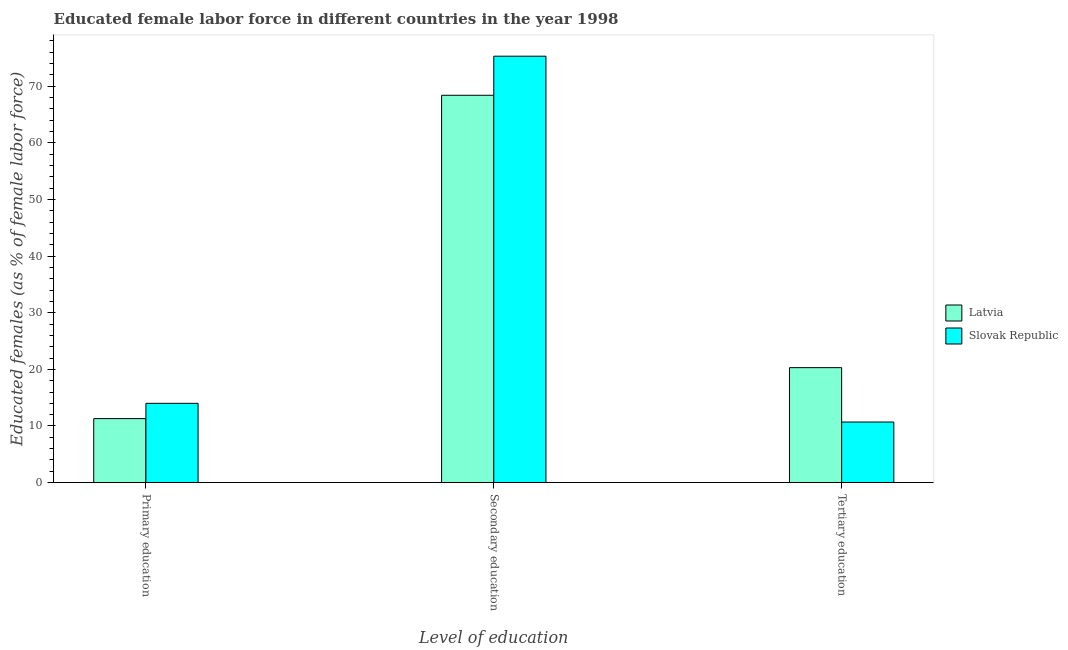How many groups of bars are there?
Provide a short and direct response. 3. Are the number of bars per tick equal to the number of legend labels?
Your response must be concise. Yes. How many bars are there on the 1st tick from the left?
Ensure brevity in your answer.  2. How many bars are there on the 3rd tick from the right?
Give a very brief answer. 2. What is the label of the 3rd group of bars from the left?
Ensure brevity in your answer.  Tertiary education. What is the percentage of female labor force who received secondary education in Latvia?
Your answer should be compact. 68.4. Across all countries, what is the maximum percentage of female labor force who received primary education?
Provide a short and direct response. 14. Across all countries, what is the minimum percentage of female labor force who received tertiary education?
Make the answer very short. 10.7. In which country was the percentage of female labor force who received tertiary education maximum?
Make the answer very short. Latvia. In which country was the percentage of female labor force who received secondary education minimum?
Ensure brevity in your answer.  Latvia. What is the total percentage of female labor force who received primary education in the graph?
Give a very brief answer. 25.3. What is the difference between the percentage of female labor force who received secondary education in Latvia and that in Slovak Republic?
Make the answer very short. -6.9. What is the difference between the percentage of female labor force who received primary education in Slovak Republic and the percentage of female labor force who received secondary education in Latvia?
Make the answer very short. -54.4. What is the average percentage of female labor force who received tertiary education per country?
Offer a terse response. 15.5. What is the difference between the percentage of female labor force who received primary education and percentage of female labor force who received tertiary education in Latvia?
Ensure brevity in your answer.  -9. In how many countries, is the percentage of female labor force who received primary education greater than 6 %?
Provide a short and direct response. 2. What is the ratio of the percentage of female labor force who received primary education in Latvia to that in Slovak Republic?
Give a very brief answer. 0.81. Is the difference between the percentage of female labor force who received secondary education in Latvia and Slovak Republic greater than the difference between the percentage of female labor force who received tertiary education in Latvia and Slovak Republic?
Your answer should be compact. No. What is the difference between the highest and the second highest percentage of female labor force who received secondary education?
Your answer should be compact. 6.9. What is the difference between the highest and the lowest percentage of female labor force who received secondary education?
Keep it short and to the point. 6.9. Is the sum of the percentage of female labor force who received secondary education in Latvia and Slovak Republic greater than the maximum percentage of female labor force who received tertiary education across all countries?
Keep it short and to the point. Yes. What does the 1st bar from the left in Primary education represents?
Offer a terse response. Latvia. What does the 1st bar from the right in Primary education represents?
Give a very brief answer. Slovak Republic. How many bars are there?
Make the answer very short. 6. Are all the bars in the graph horizontal?
Your answer should be very brief. No. How many countries are there in the graph?
Offer a very short reply. 2. Does the graph contain any zero values?
Your answer should be compact. No. Does the graph contain grids?
Make the answer very short. No. Where does the legend appear in the graph?
Make the answer very short. Center right. What is the title of the graph?
Keep it short and to the point. Educated female labor force in different countries in the year 1998. What is the label or title of the X-axis?
Ensure brevity in your answer.  Level of education. What is the label or title of the Y-axis?
Your response must be concise. Educated females (as % of female labor force). What is the Educated females (as % of female labor force) of Latvia in Primary education?
Offer a very short reply. 11.3. What is the Educated females (as % of female labor force) in Slovak Republic in Primary education?
Your answer should be very brief. 14. What is the Educated females (as % of female labor force) of Latvia in Secondary education?
Give a very brief answer. 68.4. What is the Educated females (as % of female labor force) of Slovak Republic in Secondary education?
Your response must be concise. 75.3. What is the Educated females (as % of female labor force) of Latvia in Tertiary education?
Keep it short and to the point. 20.3. What is the Educated females (as % of female labor force) of Slovak Republic in Tertiary education?
Your response must be concise. 10.7. Across all Level of education, what is the maximum Educated females (as % of female labor force) of Latvia?
Provide a short and direct response. 68.4. Across all Level of education, what is the maximum Educated females (as % of female labor force) of Slovak Republic?
Ensure brevity in your answer.  75.3. Across all Level of education, what is the minimum Educated females (as % of female labor force) in Latvia?
Offer a very short reply. 11.3. Across all Level of education, what is the minimum Educated females (as % of female labor force) of Slovak Republic?
Your response must be concise. 10.7. What is the total Educated females (as % of female labor force) of Latvia in the graph?
Provide a succinct answer. 100. What is the difference between the Educated females (as % of female labor force) of Latvia in Primary education and that in Secondary education?
Provide a succinct answer. -57.1. What is the difference between the Educated females (as % of female labor force) of Slovak Republic in Primary education and that in Secondary education?
Give a very brief answer. -61.3. What is the difference between the Educated females (as % of female labor force) of Slovak Republic in Primary education and that in Tertiary education?
Your answer should be compact. 3.3. What is the difference between the Educated females (as % of female labor force) in Latvia in Secondary education and that in Tertiary education?
Provide a succinct answer. 48.1. What is the difference between the Educated females (as % of female labor force) in Slovak Republic in Secondary education and that in Tertiary education?
Offer a very short reply. 64.6. What is the difference between the Educated females (as % of female labor force) of Latvia in Primary education and the Educated females (as % of female labor force) of Slovak Republic in Secondary education?
Offer a terse response. -64. What is the difference between the Educated females (as % of female labor force) of Latvia in Secondary education and the Educated females (as % of female labor force) of Slovak Republic in Tertiary education?
Offer a terse response. 57.7. What is the average Educated females (as % of female labor force) of Latvia per Level of education?
Offer a very short reply. 33.33. What is the average Educated females (as % of female labor force) in Slovak Republic per Level of education?
Give a very brief answer. 33.33. What is the difference between the Educated females (as % of female labor force) in Latvia and Educated females (as % of female labor force) in Slovak Republic in Primary education?
Offer a terse response. -2.7. What is the ratio of the Educated females (as % of female labor force) in Latvia in Primary education to that in Secondary education?
Provide a short and direct response. 0.17. What is the ratio of the Educated females (as % of female labor force) in Slovak Republic in Primary education to that in Secondary education?
Offer a very short reply. 0.19. What is the ratio of the Educated females (as % of female labor force) of Latvia in Primary education to that in Tertiary education?
Make the answer very short. 0.56. What is the ratio of the Educated females (as % of female labor force) of Slovak Republic in Primary education to that in Tertiary education?
Offer a very short reply. 1.31. What is the ratio of the Educated females (as % of female labor force) of Latvia in Secondary education to that in Tertiary education?
Offer a terse response. 3.37. What is the ratio of the Educated females (as % of female labor force) in Slovak Republic in Secondary education to that in Tertiary education?
Provide a short and direct response. 7.04. What is the difference between the highest and the second highest Educated females (as % of female labor force) in Latvia?
Your answer should be very brief. 48.1. What is the difference between the highest and the second highest Educated females (as % of female labor force) of Slovak Republic?
Provide a short and direct response. 61.3. What is the difference between the highest and the lowest Educated females (as % of female labor force) in Latvia?
Give a very brief answer. 57.1. What is the difference between the highest and the lowest Educated females (as % of female labor force) of Slovak Republic?
Ensure brevity in your answer.  64.6. 